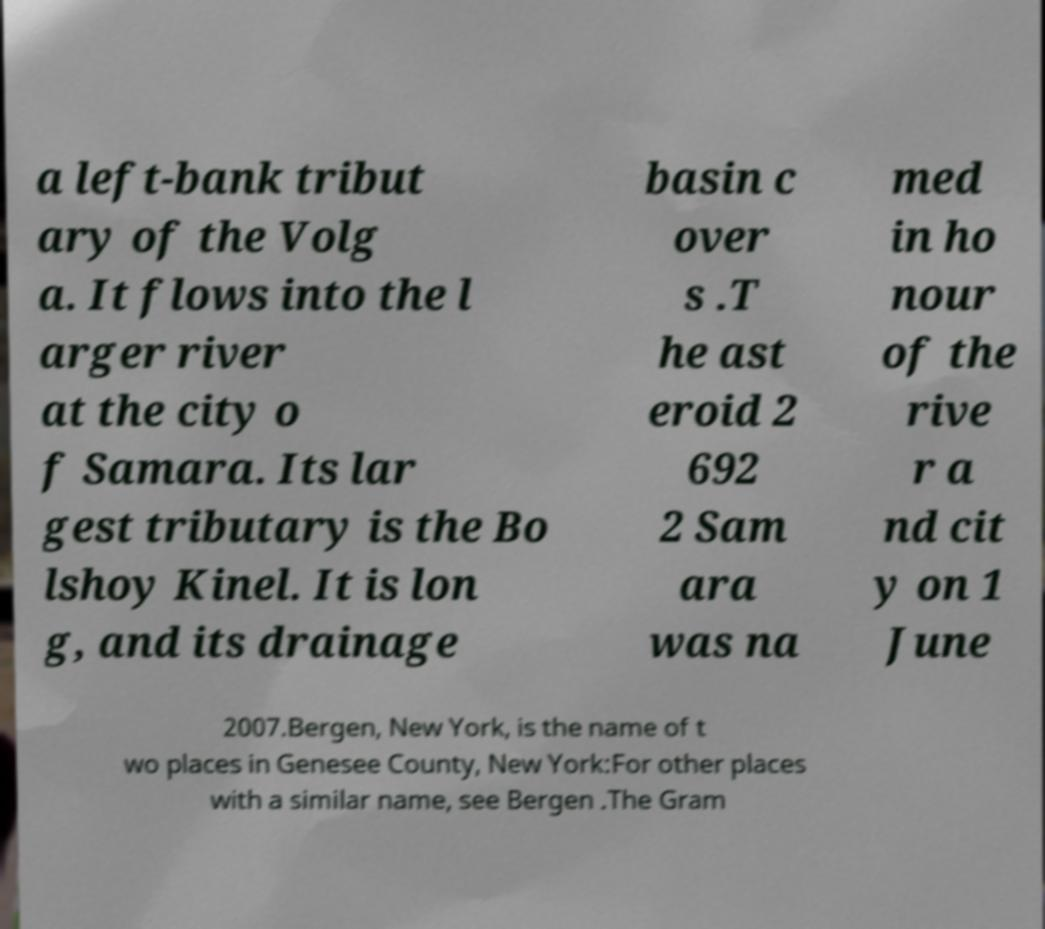Could you extract and type out the text from this image? a left-bank tribut ary of the Volg a. It flows into the l arger river at the city o f Samara. Its lar gest tributary is the Bo lshoy Kinel. It is lon g, and its drainage basin c over s .T he ast eroid 2 692 2 Sam ara was na med in ho nour of the rive r a nd cit y on 1 June 2007.Bergen, New York, is the name of t wo places in Genesee County, New York:For other places with a similar name, see Bergen .The Gram 